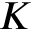Convert formula to latex. <formula><loc_0><loc_0><loc_500><loc_500>K</formula> 